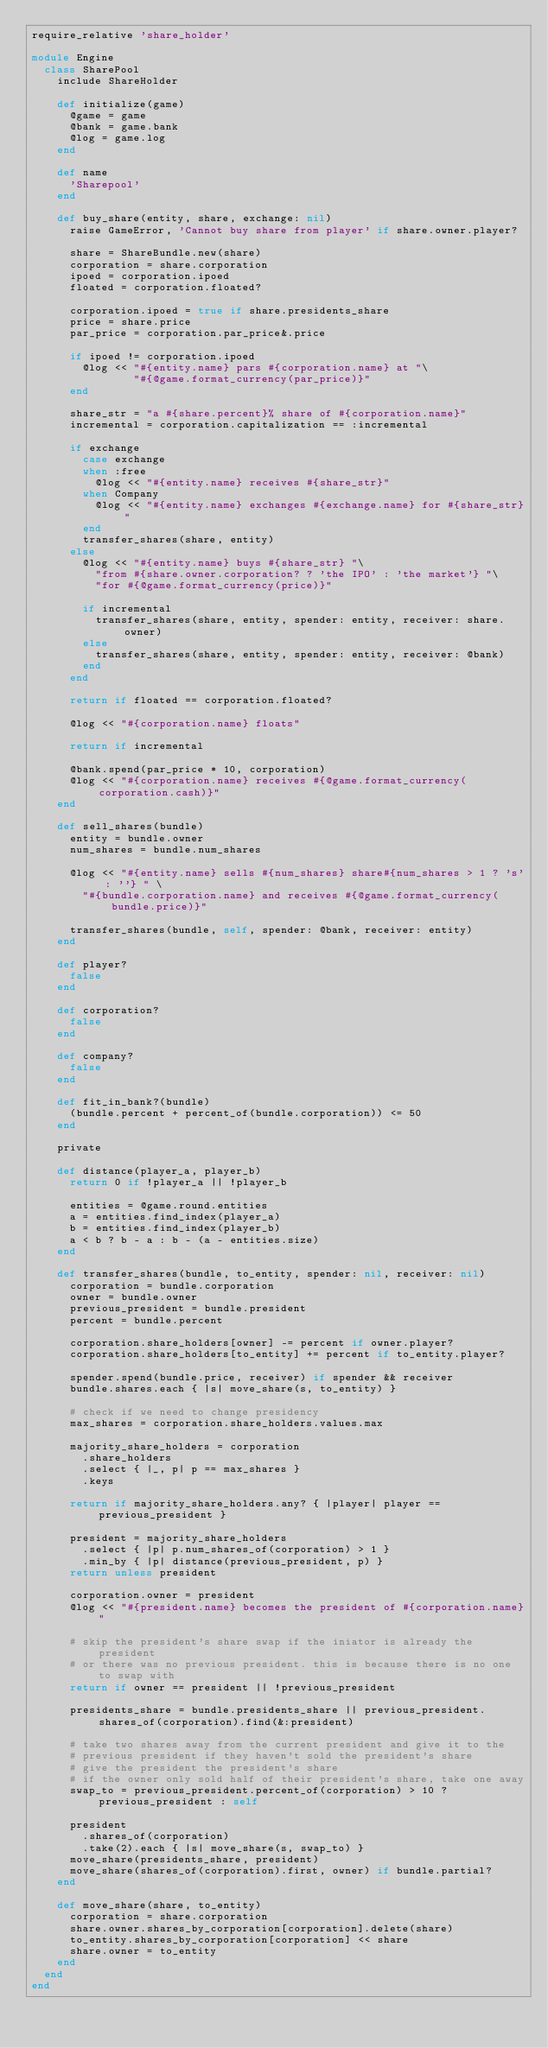<code> <loc_0><loc_0><loc_500><loc_500><_Ruby_>require_relative 'share_holder'

module Engine
  class SharePool
    include ShareHolder

    def initialize(game)
      @game = game
      @bank = game.bank
      @log = game.log
    end

    def name
      'Sharepool'
    end

    def buy_share(entity, share, exchange: nil)
      raise GameError, 'Cannot buy share from player' if share.owner.player?

      share = ShareBundle.new(share)
      corporation = share.corporation
      ipoed = corporation.ipoed
      floated = corporation.floated?

      corporation.ipoed = true if share.presidents_share
      price = share.price
      par_price = corporation.par_price&.price

      if ipoed != corporation.ipoed
        @log << "#{entity.name} pars #{corporation.name} at "\
                "#{@game.format_currency(par_price)}"
      end

      share_str = "a #{share.percent}% share of #{corporation.name}"
      incremental = corporation.capitalization == :incremental

      if exchange
        case exchange
        when :free
          @log << "#{entity.name} receives #{share_str}"
        when Company
          @log << "#{entity.name} exchanges #{exchange.name} for #{share_str}"
        end
        transfer_shares(share, entity)
      else
        @log << "#{entity.name} buys #{share_str} "\
          "from #{share.owner.corporation? ? 'the IPO' : 'the market'} "\
          "for #{@game.format_currency(price)}"

        if incremental
          transfer_shares(share, entity, spender: entity, receiver: share.owner)
        else
          transfer_shares(share, entity, spender: entity, receiver: @bank)
        end
      end

      return if floated == corporation.floated?

      @log << "#{corporation.name} floats"

      return if incremental

      @bank.spend(par_price * 10, corporation)
      @log << "#{corporation.name} receives #{@game.format_currency(corporation.cash)}"
    end

    def sell_shares(bundle)
      entity = bundle.owner
      num_shares = bundle.num_shares

      @log << "#{entity.name} sells #{num_shares} share#{num_shares > 1 ? 's' : ''} " \
        "#{bundle.corporation.name} and receives #{@game.format_currency(bundle.price)}"

      transfer_shares(bundle, self, spender: @bank, receiver: entity)
    end

    def player?
      false
    end

    def corporation?
      false
    end

    def company?
      false
    end

    def fit_in_bank?(bundle)
      (bundle.percent + percent_of(bundle.corporation)) <= 50
    end

    private

    def distance(player_a, player_b)
      return 0 if !player_a || !player_b

      entities = @game.round.entities
      a = entities.find_index(player_a)
      b = entities.find_index(player_b)
      a < b ? b - a : b - (a - entities.size)
    end

    def transfer_shares(bundle, to_entity, spender: nil, receiver: nil)
      corporation = bundle.corporation
      owner = bundle.owner
      previous_president = bundle.president
      percent = bundle.percent

      corporation.share_holders[owner] -= percent if owner.player?
      corporation.share_holders[to_entity] += percent if to_entity.player?

      spender.spend(bundle.price, receiver) if spender && receiver
      bundle.shares.each { |s| move_share(s, to_entity) }

      # check if we need to change presidency
      max_shares = corporation.share_holders.values.max

      majority_share_holders = corporation
        .share_holders
        .select { |_, p| p == max_shares }
        .keys

      return if majority_share_holders.any? { |player| player == previous_president }

      president = majority_share_holders
        .select { |p| p.num_shares_of(corporation) > 1 }
        .min_by { |p| distance(previous_president, p) }
      return unless president

      corporation.owner = president
      @log << "#{president.name} becomes the president of #{corporation.name}"

      # skip the president's share swap if the iniator is already the president
      # or there was no previous president. this is because there is no one to swap with
      return if owner == president || !previous_president

      presidents_share = bundle.presidents_share || previous_president.shares_of(corporation).find(&:president)

      # take two shares away from the current president and give it to the
      # previous president if they haven't sold the president's share
      # give the president the president's share
      # if the owner only sold half of their president's share, take one away
      swap_to = previous_president.percent_of(corporation) > 10 ? previous_president : self

      president
        .shares_of(corporation)
        .take(2).each { |s| move_share(s, swap_to) }
      move_share(presidents_share, president)
      move_share(shares_of(corporation).first, owner) if bundle.partial?
    end

    def move_share(share, to_entity)
      corporation = share.corporation
      share.owner.shares_by_corporation[corporation].delete(share)
      to_entity.shares_by_corporation[corporation] << share
      share.owner = to_entity
    end
  end
end
</code> 